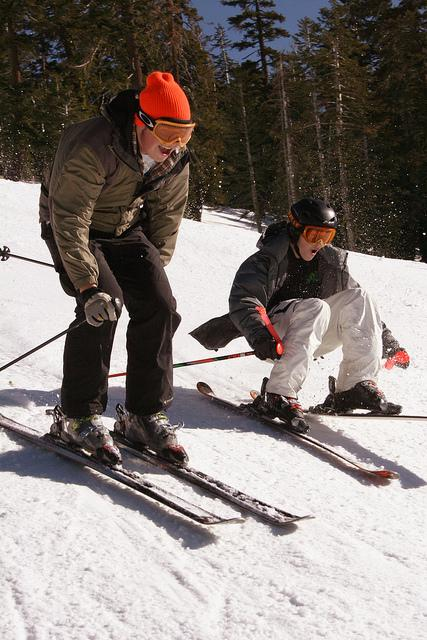What is this sport name?

Choices:
A) skating
B) surfing
C) skiing
D) swimming skiing 